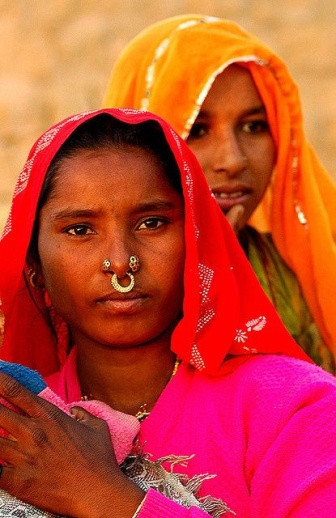Create a fictional dreamscape inspired by the colors and themes in the image. In a mystical realm where the sands shimmer under a twilight sky, there exists an ancient kingdom draped in the colors of dusk and dawn. Here, the air is thick with the scent of blooming jasmine and the echoing melodies of ancient songs. The central palace, built from golden sandstone, radiates a soft, luminous glow as if kissed by eternal sunlight. In this dreamscape, two guardian spirits, reminding the women in the image, protect the kingdom’s sacred traditions. Adorned in vibrant gowns of pink and orange, they dance by the oasis, their every twirl creating ripples that merge the past with the present. These guardians are said to possess the wisdom of generations, their stories weaving the very fabric of this fantastical world. 